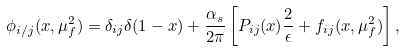Convert formula to latex. <formula><loc_0><loc_0><loc_500><loc_500>\phi _ { i / j } ( x , \mu _ { f } ^ { 2 } ) = \delta _ { i j } \delta ( 1 - x ) + \frac { \alpha _ { s } } { 2 \pi } \left [ P _ { i j } ( x ) \frac { 2 } { \epsilon } + f _ { i j } ( x , \mu _ { f } ^ { 2 } ) \right ] ,</formula> 